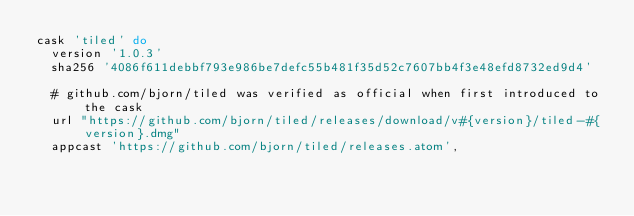<code> <loc_0><loc_0><loc_500><loc_500><_Ruby_>cask 'tiled' do
  version '1.0.3'
  sha256 '4086f611debbf793e986be7defc55b481f35d52c7607bb4f3e48efd8732ed9d4'

  # github.com/bjorn/tiled was verified as official when first introduced to the cask
  url "https://github.com/bjorn/tiled/releases/download/v#{version}/tiled-#{version}.dmg"
  appcast 'https://github.com/bjorn/tiled/releases.atom',</code> 